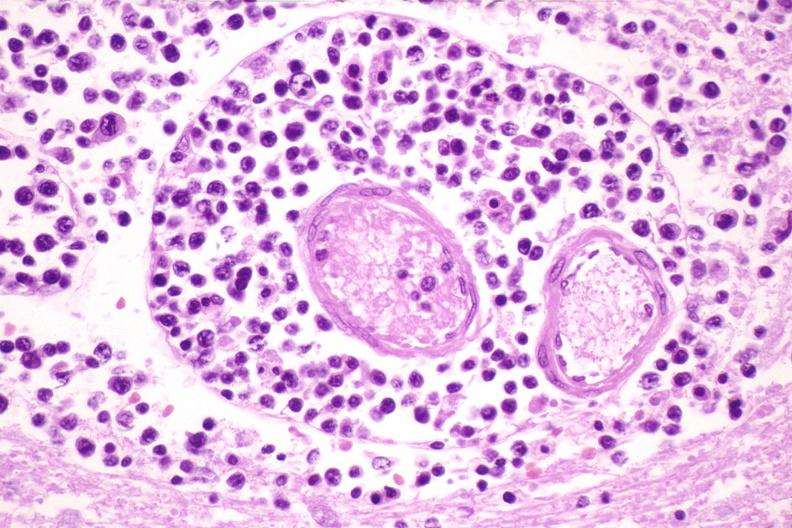does this image show brain lymphoma?
Answer the question using a single word or phrase. Yes 